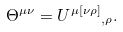<formula> <loc_0><loc_0><loc_500><loc_500>\Theta ^ { \mu \nu } = { U ^ { \mu [ \nu \rho ] } } _ { , \rho } .</formula> 